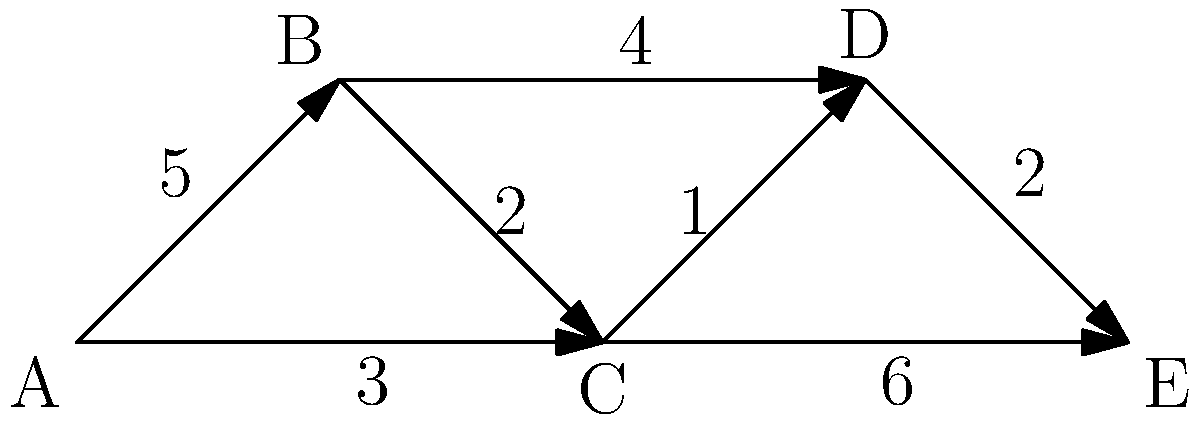In this juicy celebrity scandal network, each node represents a celebrity, and each edge represents a scandalous connection between them. The weight of each edge indicates the intensity of the scandal on a scale of 1-6. Which celebrity is at the center of the most intense scandals, and what's the total intensity of their direct connections? To solve this scandalous puzzle, let's follow these steps:

1. Identify all celebrities (nodes) in the network:
   A, B, C, D, and E

2. Calculate the total intensity of direct connections for each celebrity:

   A: Connected to B (5) and C (3)
      Total: 5 + 3 = 8

   B: Connected to A (5), C (2), and D (4)
      Total: 5 + 2 + 4 = 11

   C: Connected to A (3), B (2), D (1), and E (6)
      Total: 3 + 2 + 1 + 6 = 12

   D: Connected to B (4), C (1), and E (2)
      Total: 4 + 1 + 2 = 7

   E: Connected to C (6) and D (2)
      Total: 6 + 2 = 8

3. Identify the celebrity with the highest total intensity:
   Celebrity C has the highest total intensity of 12.

Therefore, Celebrity C is at the center of the most intense scandals, with a total intensity of 12 from their direct connections.
Answer: Celebrity C, 12 